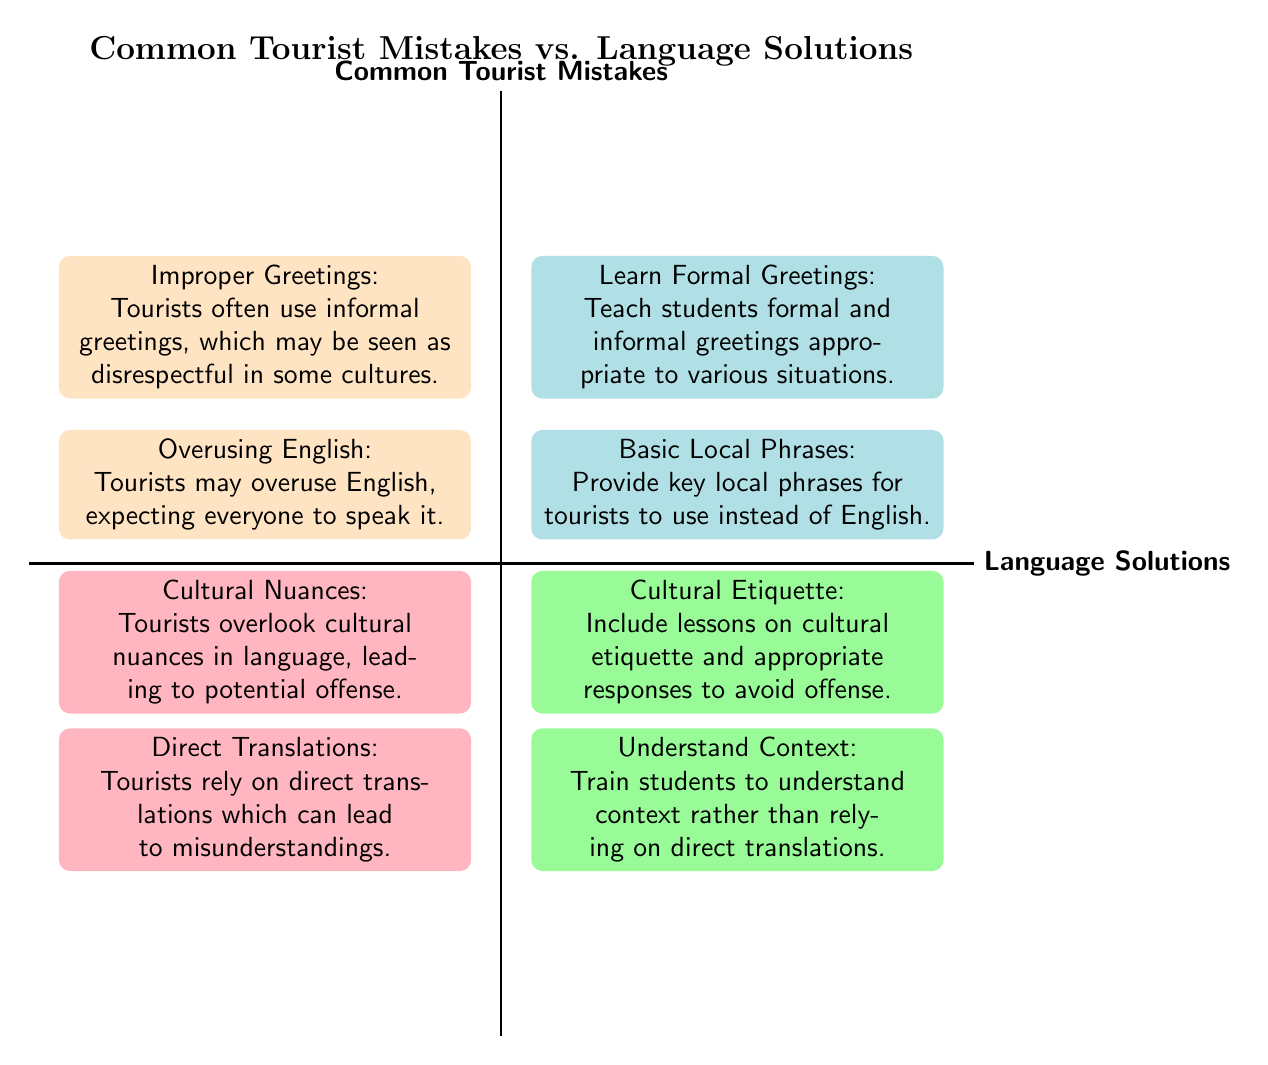What is the common mistake associated with cultural nuances? The node associated with cultural nuances in the diagram states that tourists overlook cultural nuances in language, leading to potential offense.
Answer: Cultural Nuances: Tourists overlook cultural nuances in language, leading to potential offense What is the language solution for improper greetings? The node for improper greetings is paired with the solution of learning formal greetings, where students are taught formal and informal greetings appropriate to various situations.
Answer: Learn Formal Greetings: Teach students formal and informal greetings appropriate to various situations How many common tourist mistakes are listed? By counting the nodes in the section labeled "Common Tourist Mistakes," there are a total of four mistakes presented in the diagram.
Answer: 4 What language solution corresponds to overusing English? The solution to the mistake of overusing English in the diagram is to provide basic local phrases for tourists to use instead of English, which is explicitly noted in the related node.
Answer: Basic Local Phrases: Provide key local phrases for tourists to use instead of English Which two mistakes are positioned in the same row within the quadrant chart? In the diagram, improper greetings and overusing English are both positioned in the same row, indicating their direct relationship to language solutions that relate to social interactions and communication expectations.
Answer: Improper Greetings and Overusing English 